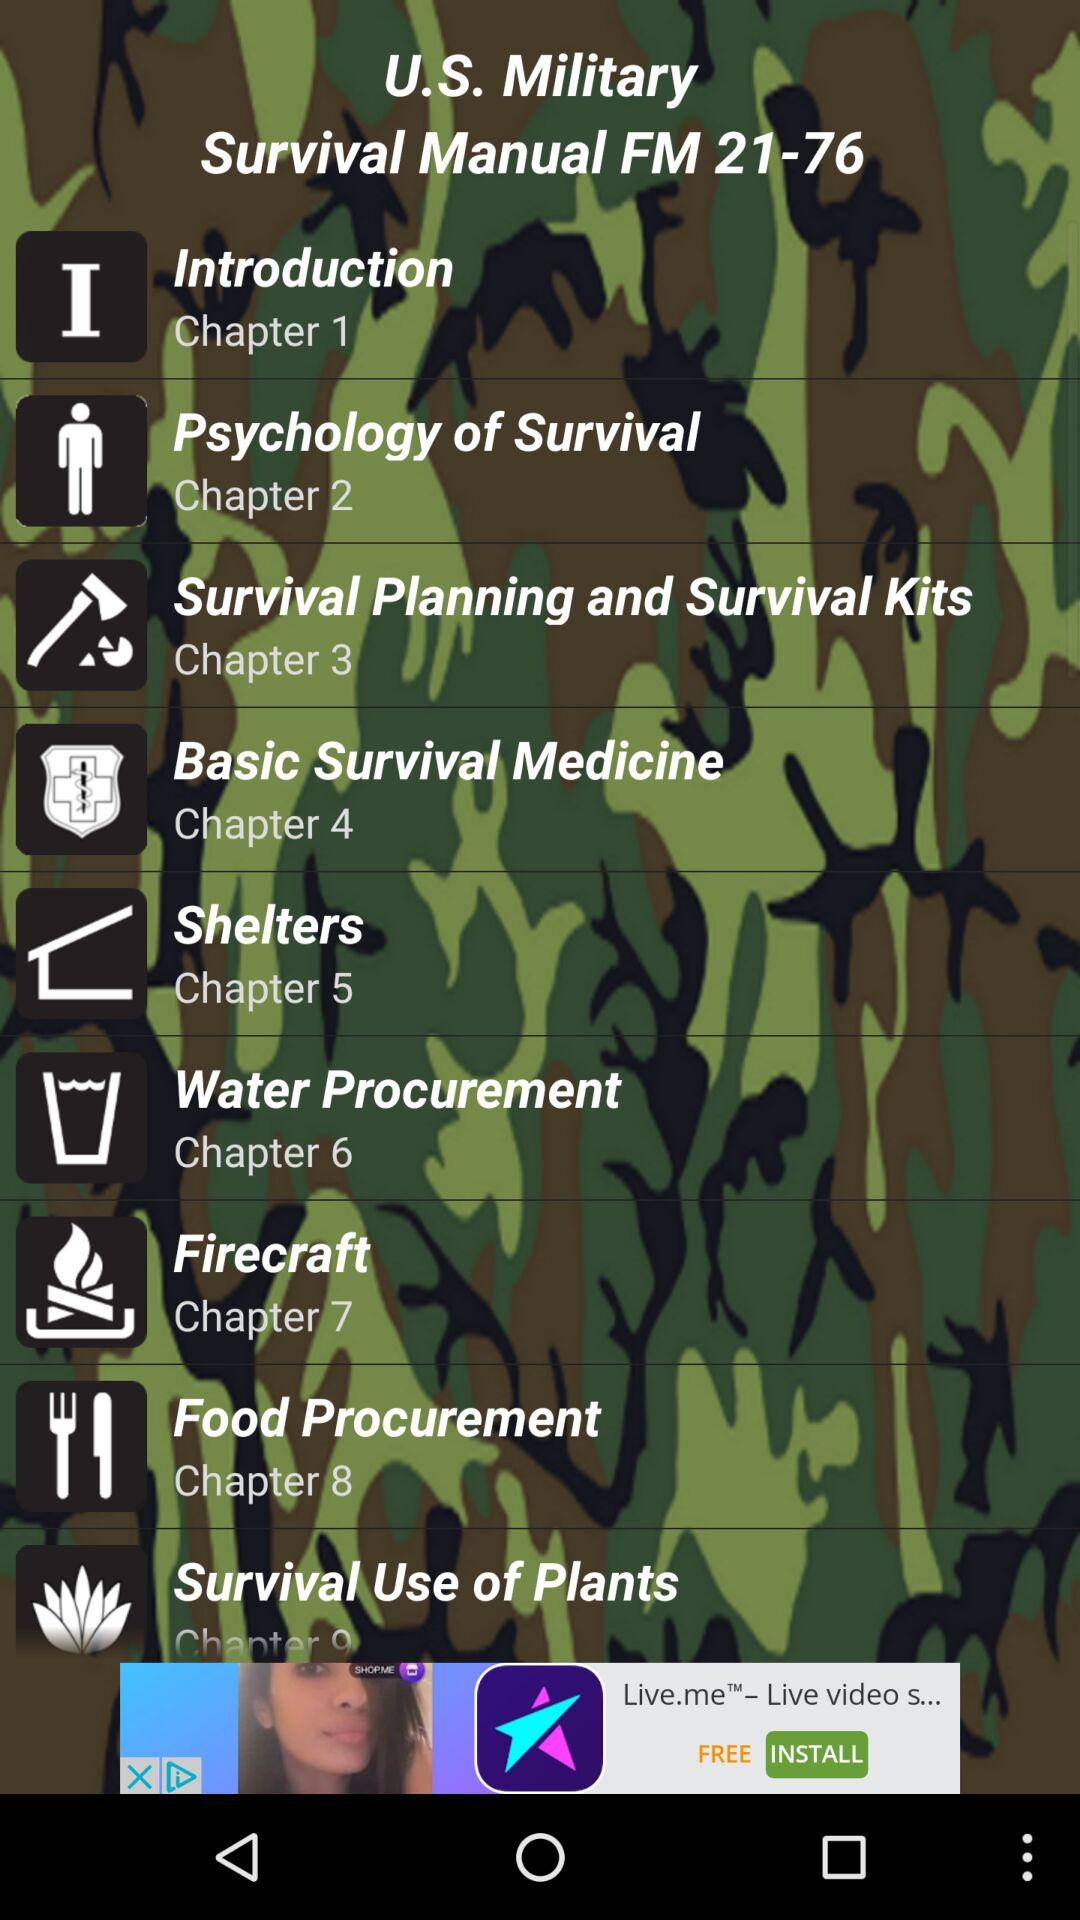How many chapters are there in the survival manual?
Answer the question using a single word or phrase. 9 